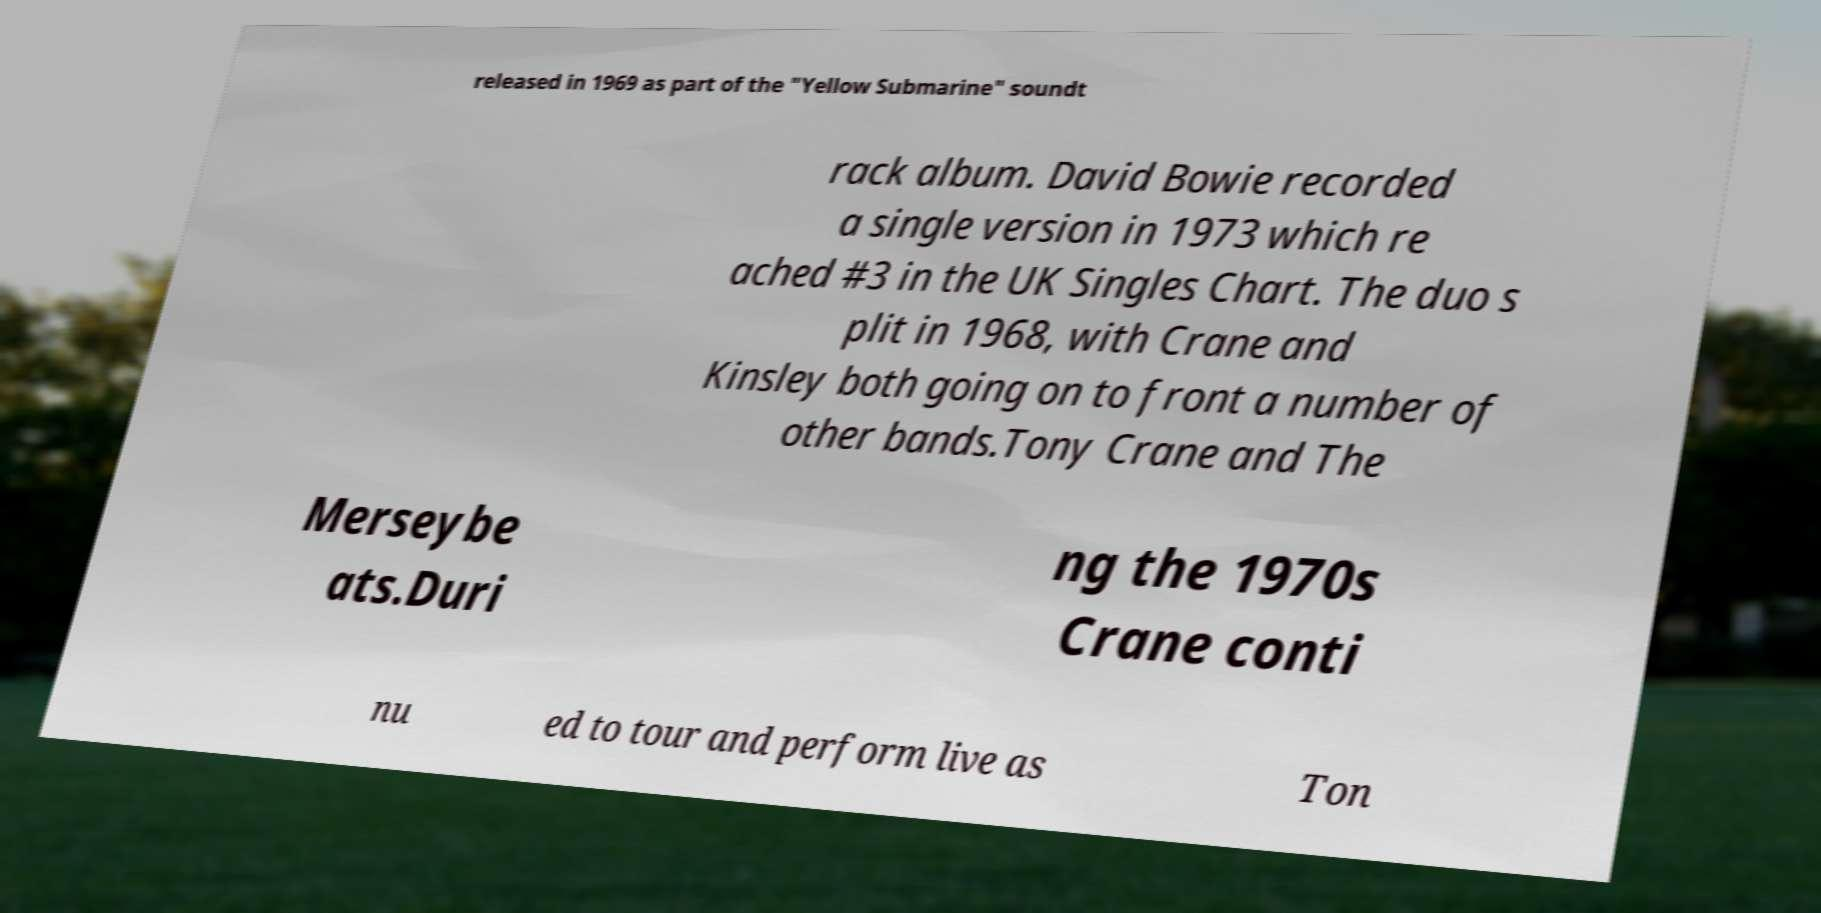I need the written content from this picture converted into text. Can you do that? released in 1969 as part of the "Yellow Submarine" soundt rack album. David Bowie recorded a single version in 1973 which re ached #3 in the UK Singles Chart. The duo s plit in 1968, with Crane and Kinsley both going on to front a number of other bands.Tony Crane and The Merseybe ats.Duri ng the 1970s Crane conti nu ed to tour and perform live as Ton 